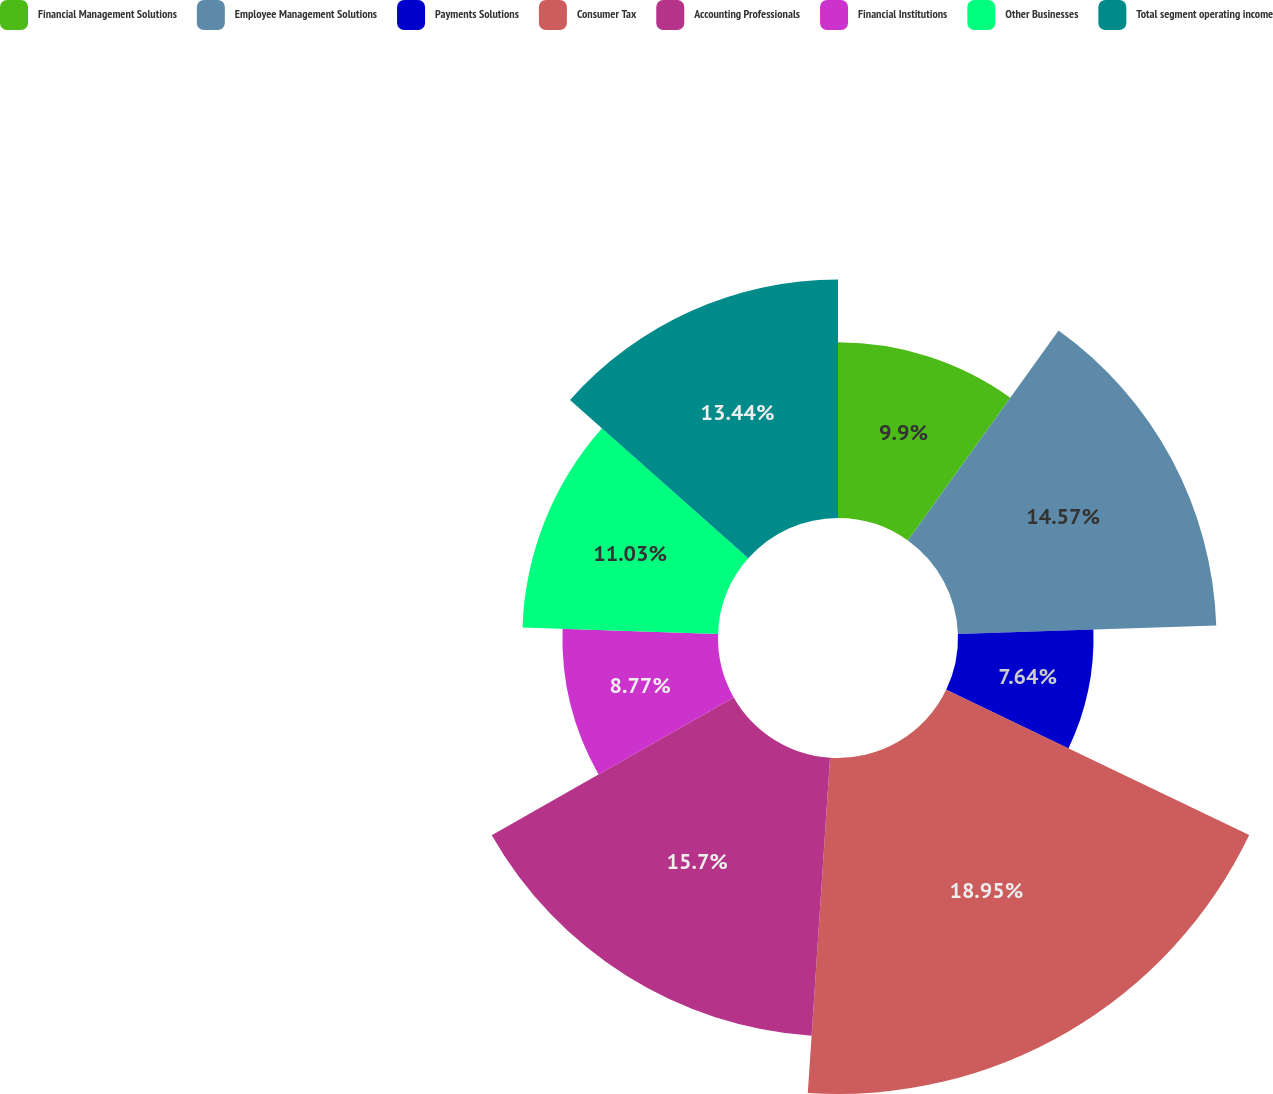<chart> <loc_0><loc_0><loc_500><loc_500><pie_chart><fcel>Financial Management Solutions<fcel>Employee Management Solutions<fcel>Payments Solutions<fcel>Consumer Tax<fcel>Accounting Professionals<fcel>Financial Institutions<fcel>Other Businesses<fcel>Total segment operating income<nl><fcel>9.9%<fcel>14.57%<fcel>7.64%<fcel>18.94%<fcel>15.7%<fcel>8.77%<fcel>11.03%<fcel>13.44%<nl></chart> 